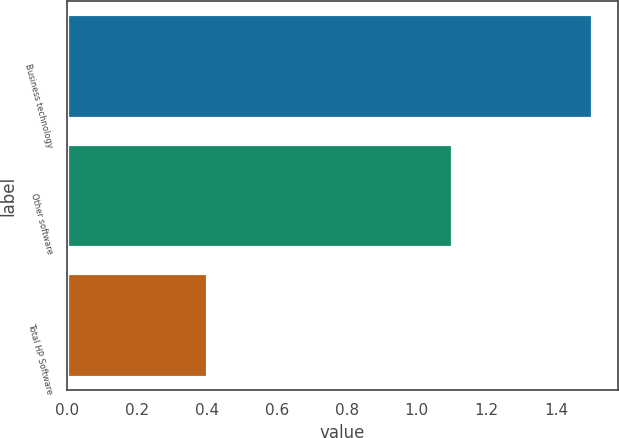Convert chart to OTSL. <chart><loc_0><loc_0><loc_500><loc_500><bar_chart><fcel>Business technology<fcel>Other software<fcel>Total HP Software<nl><fcel>1.5<fcel>1.1<fcel>0.4<nl></chart> 